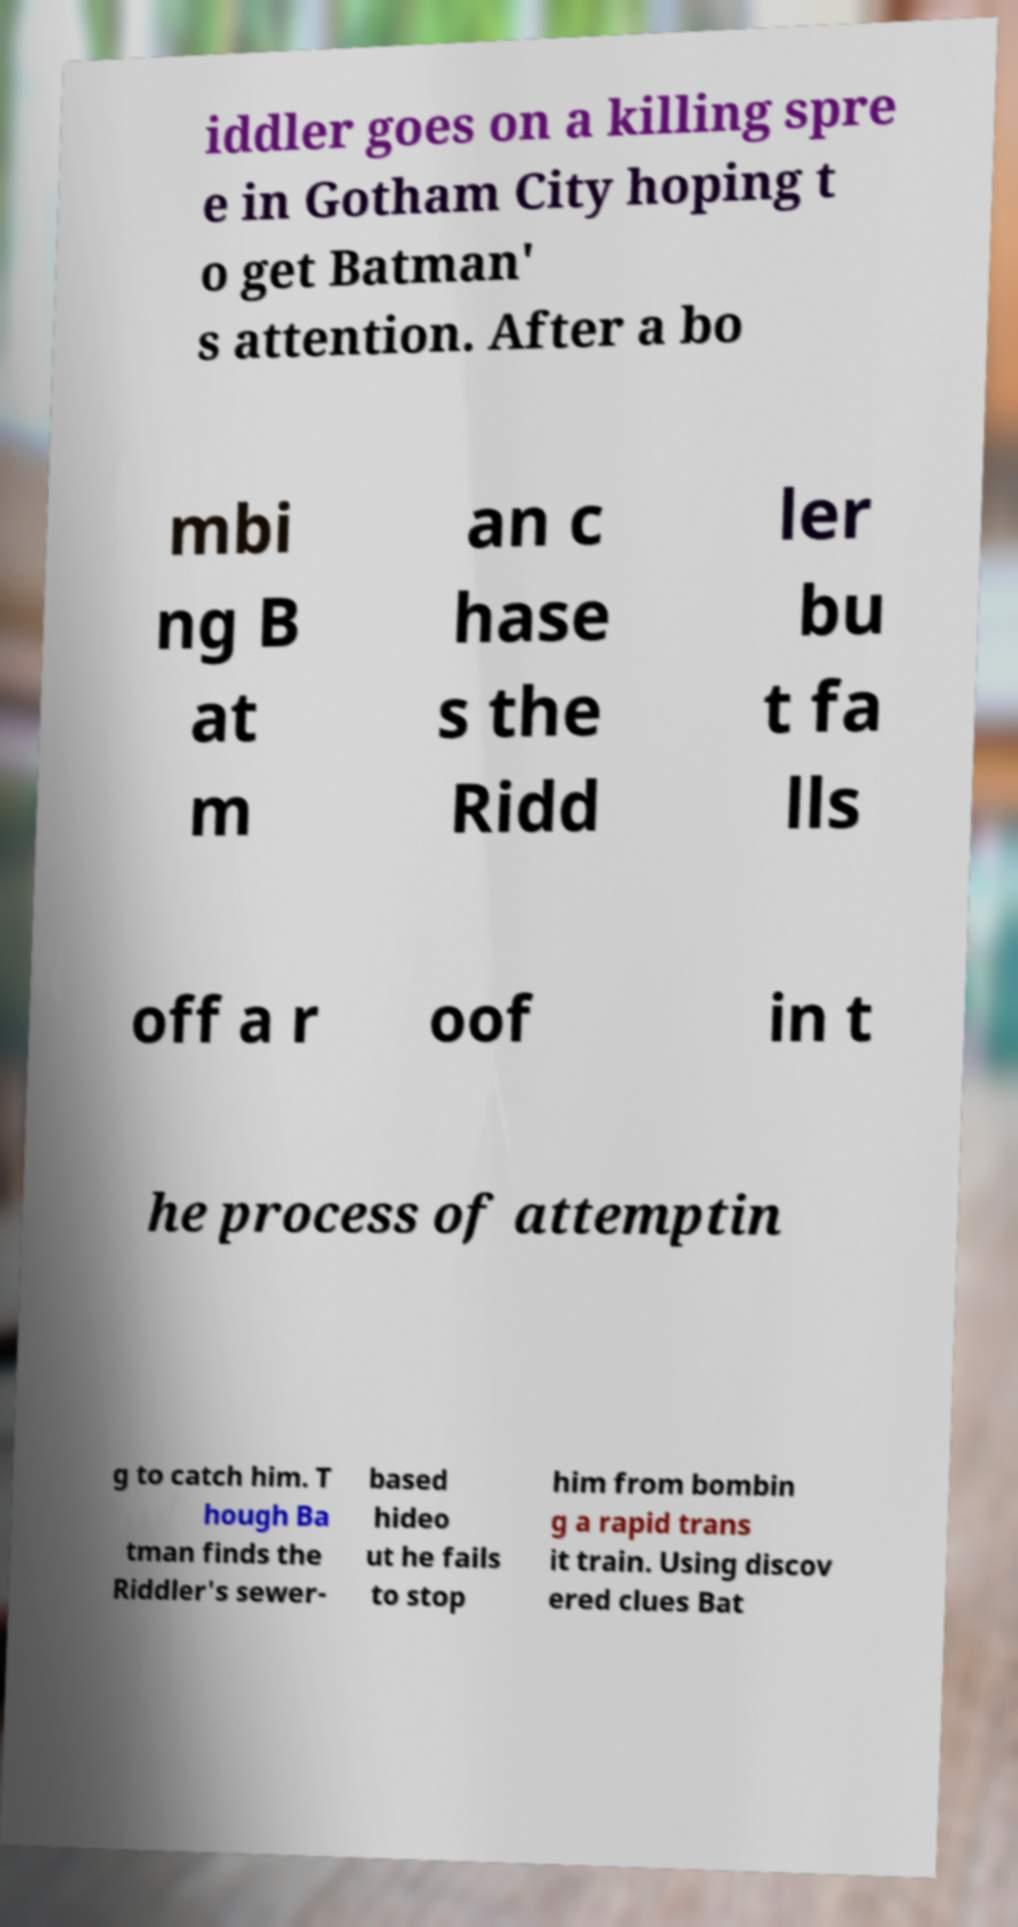Could you assist in decoding the text presented in this image and type it out clearly? iddler goes on a killing spre e in Gotham City hoping t o get Batman' s attention. After a bo mbi ng B at m an c hase s the Ridd ler bu t fa lls off a r oof in t he process of attemptin g to catch him. T hough Ba tman finds the Riddler's sewer- based hideo ut he fails to stop him from bombin g a rapid trans it train. Using discov ered clues Bat 